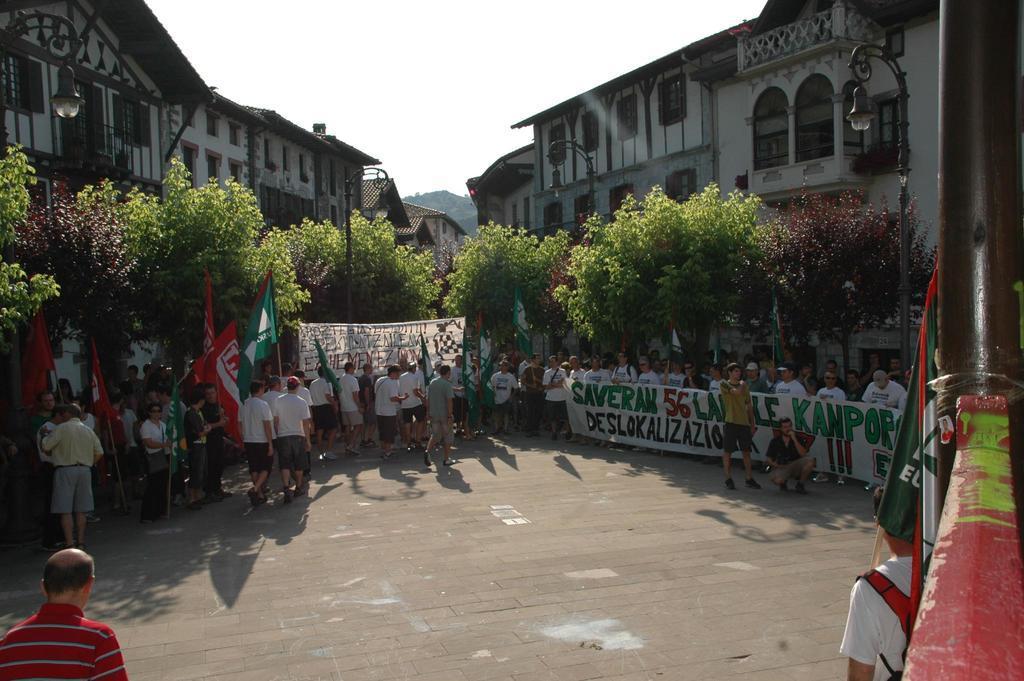In one or two sentences, can you explain what this image depicts? In the center of the image we can see group of persons walking and standing on the road. On the right side of the image we can see person, holding a flag. On the left side of the image we can see a person on the road. In the background we can see trees, buildings, hill and sky. 